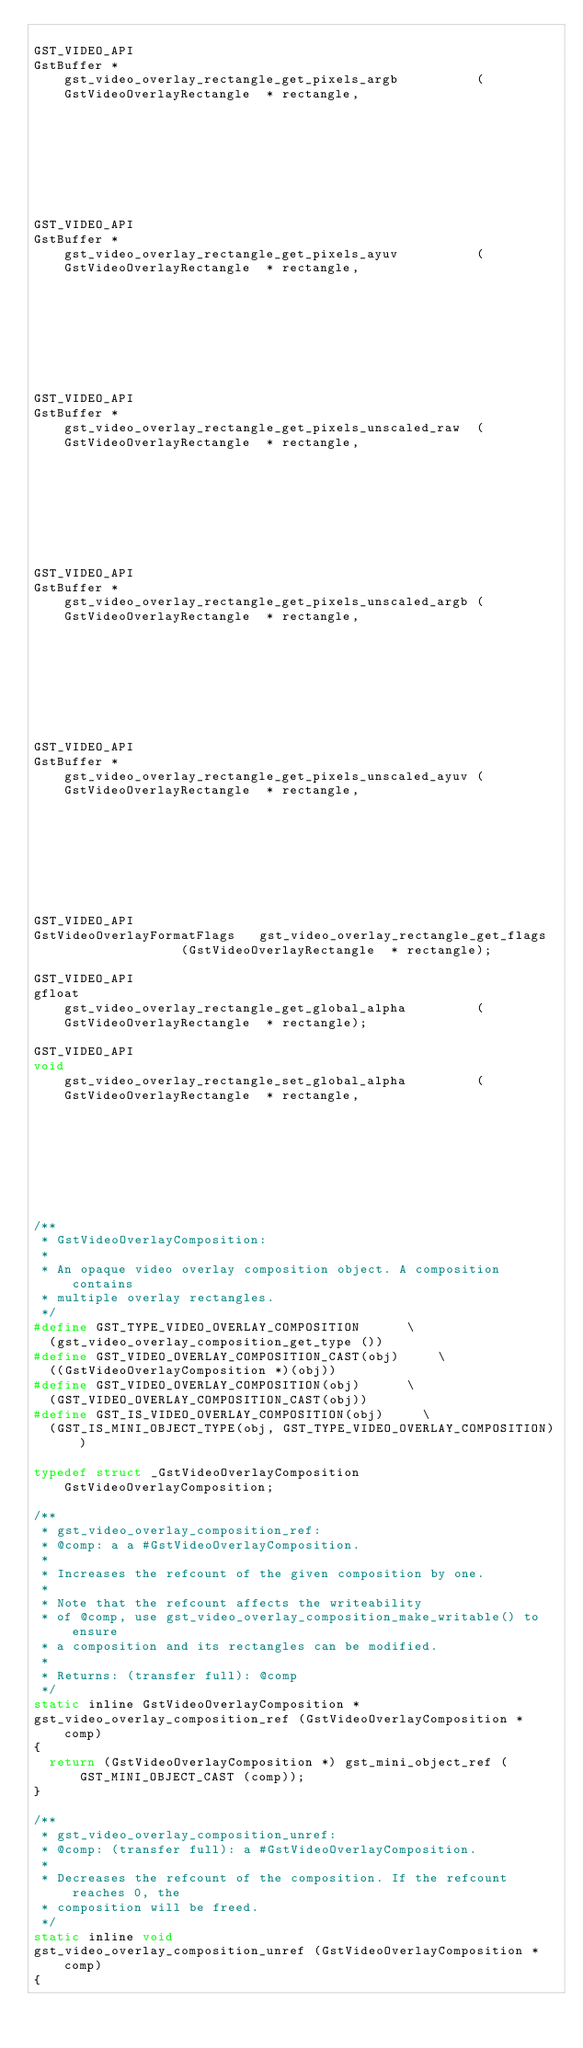<code> <loc_0><loc_0><loc_500><loc_500><_C_>
GST_VIDEO_API
GstBuffer *                  gst_video_overlay_rectangle_get_pixels_argb          (GstVideoOverlayRectangle  * rectangle,
                                                                                   GstVideoOverlayFormatFlags  flags);

GST_VIDEO_API
GstBuffer *                  gst_video_overlay_rectangle_get_pixels_ayuv          (GstVideoOverlayRectangle  * rectangle,
                                                                                   GstVideoOverlayFormatFlags  flags);

GST_VIDEO_API
GstBuffer *                  gst_video_overlay_rectangle_get_pixels_unscaled_raw  (GstVideoOverlayRectangle  * rectangle,
                                                                                   GstVideoOverlayFormatFlags  flags);

GST_VIDEO_API
GstBuffer *                  gst_video_overlay_rectangle_get_pixels_unscaled_argb (GstVideoOverlayRectangle  * rectangle,
                                                                                   GstVideoOverlayFormatFlags  flags);

GST_VIDEO_API
GstBuffer *                  gst_video_overlay_rectangle_get_pixels_unscaled_ayuv (GstVideoOverlayRectangle  * rectangle,
                                                                                   GstVideoOverlayFormatFlags  flags);

GST_VIDEO_API
GstVideoOverlayFormatFlags   gst_video_overlay_rectangle_get_flags                (GstVideoOverlayRectangle  * rectangle);

GST_VIDEO_API
gfloat                       gst_video_overlay_rectangle_get_global_alpha         (GstVideoOverlayRectangle  * rectangle);

GST_VIDEO_API
void                         gst_video_overlay_rectangle_set_global_alpha         (GstVideoOverlayRectangle  * rectangle,
                                                                                   gfloat                      global_alpha);

/**
 * GstVideoOverlayComposition:
 *
 * An opaque video overlay composition object. A composition contains
 * multiple overlay rectangles.
 */
#define GST_TYPE_VIDEO_OVERLAY_COMPOSITION			\
  (gst_video_overlay_composition_get_type ())
#define GST_VIDEO_OVERLAY_COMPOSITION_CAST(obj)			\
  ((GstVideoOverlayComposition *)(obj))
#define GST_VIDEO_OVERLAY_COMPOSITION(obj)			\
  (GST_VIDEO_OVERLAY_COMPOSITION_CAST(obj))
#define GST_IS_VIDEO_OVERLAY_COMPOSITION(obj)			\
  (GST_IS_MINI_OBJECT_TYPE(obj, GST_TYPE_VIDEO_OVERLAY_COMPOSITION))

typedef struct _GstVideoOverlayComposition      GstVideoOverlayComposition;

/**
 * gst_video_overlay_composition_ref:
 * @comp: a a #GstVideoOverlayComposition.
 *
 * Increases the refcount of the given composition by one.
 *
 * Note that the refcount affects the writeability
 * of @comp, use gst_video_overlay_composition_make_writable() to ensure
 * a composition and its rectangles can be modified.
 *
 * Returns: (transfer full): @comp
 */
static inline GstVideoOverlayComposition *
gst_video_overlay_composition_ref (GstVideoOverlayComposition * comp)
{
  return (GstVideoOverlayComposition *) gst_mini_object_ref (GST_MINI_OBJECT_CAST (comp));
}

/**
 * gst_video_overlay_composition_unref:
 * @comp: (transfer full): a #GstVideoOverlayComposition.
 *
 * Decreases the refcount of the composition. If the refcount reaches 0, the
 * composition will be freed.
 */
static inline void
gst_video_overlay_composition_unref (GstVideoOverlayComposition * comp)
{</code> 